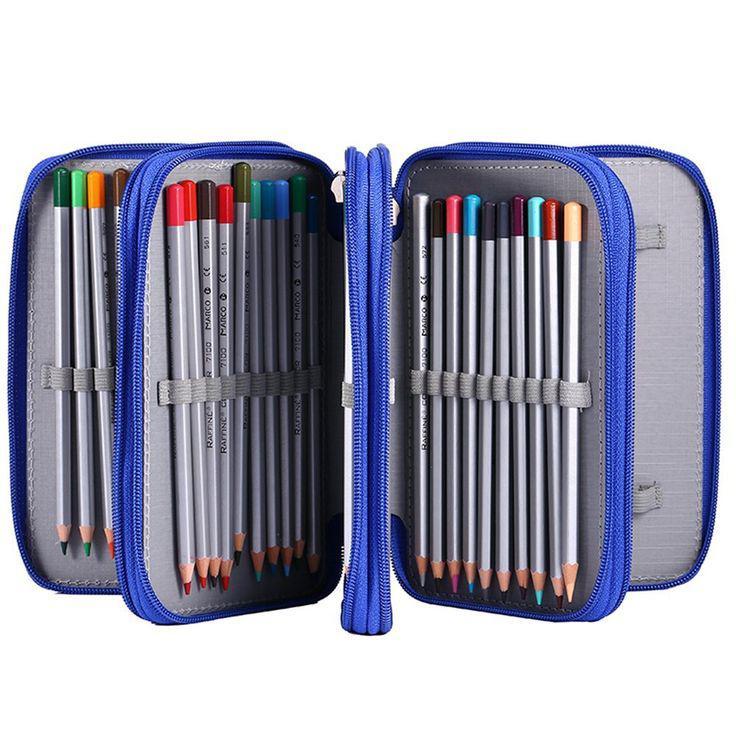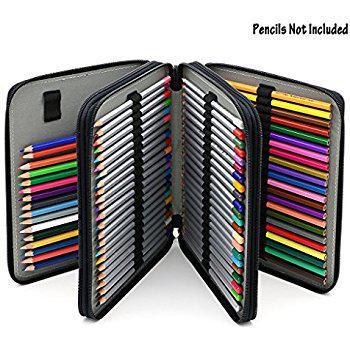The first image is the image on the left, the second image is the image on the right. Given the left and right images, does the statement "One container has a pair of scissors." hold true? Answer yes or no. No. The first image is the image on the left, the second image is the image on the right. For the images shown, is this caption "There is at least one pair of scissors inside of the binder in one of the images." true? Answer yes or no. No. 